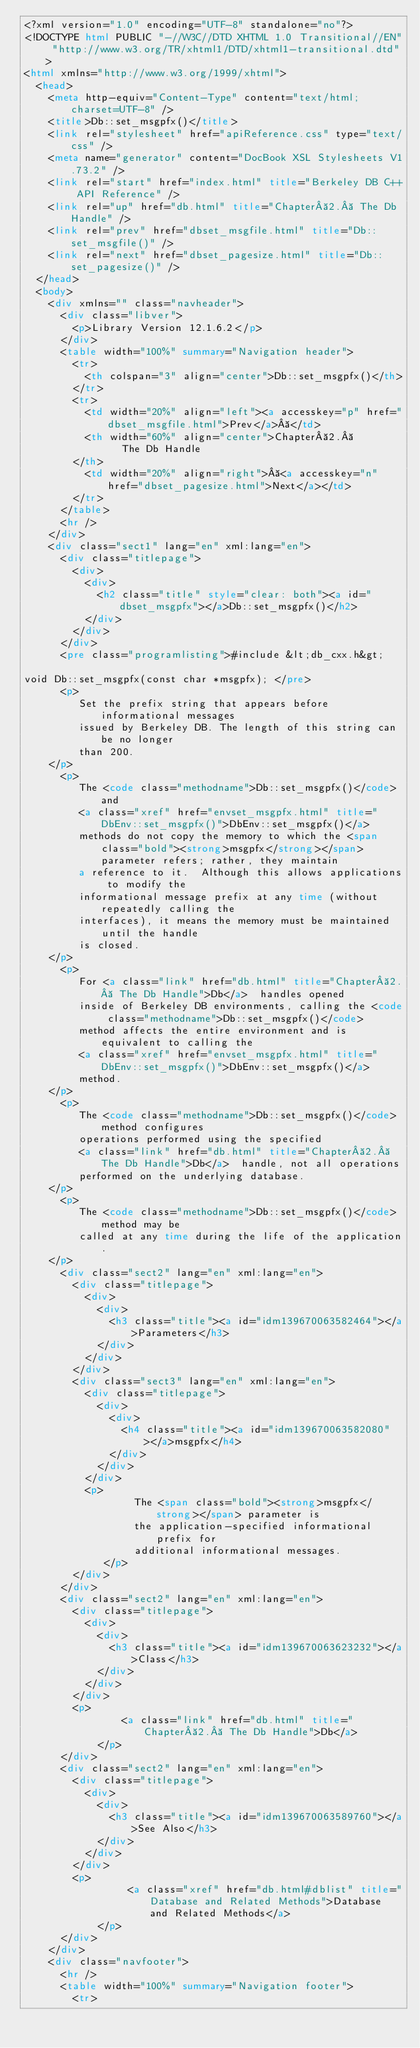Convert code to text. <code><loc_0><loc_0><loc_500><loc_500><_HTML_><?xml version="1.0" encoding="UTF-8" standalone="no"?>
<!DOCTYPE html PUBLIC "-//W3C//DTD XHTML 1.0 Transitional//EN" "http://www.w3.org/TR/xhtml1/DTD/xhtml1-transitional.dtd">
<html xmlns="http://www.w3.org/1999/xhtml">
  <head>
    <meta http-equiv="Content-Type" content="text/html; charset=UTF-8" />
    <title>Db::set_msgpfx()</title>
    <link rel="stylesheet" href="apiReference.css" type="text/css" />
    <meta name="generator" content="DocBook XSL Stylesheets V1.73.2" />
    <link rel="start" href="index.html" title="Berkeley DB C++ API Reference" />
    <link rel="up" href="db.html" title="Chapter 2.  The Db Handle" />
    <link rel="prev" href="dbset_msgfile.html" title="Db::set_msgfile()" />
    <link rel="next" href="dbset_pagesize.html" title="Db::set_pagesize()" />
  </head>
  <body>
    <div xmlns="" class="navheader">
      <div class="libver">
        <p>Library Version 12.1.6.2</p>
      </div>
      <table width="100%" summary="Navigation header">
        <tr>
          <th colspan="3" align="center">Db::set_msgpfx()</th>
        </tr>
        <tr>
          <td width="20%" align="left"><a accesskey="p" href="dbset_msgfile.html">Prev</a> </td>
          <th width="60%" align="center">Chapter 2. 
                The Db Handle
        </th>
          <td width="20%" align="right"> <a accesskey="n" href="dbset_pagesize.html">Next</a></td>
        </tr>
      </table>
      <hr />
    </div>
    <div class="sect1" lang="en" xml:lang="en">
      <div class="titlepage">
        <div>
          <div>
            <h2 class="title" style="clear: both"><a id="dbset_msgpfx"></a>Db::set_msgpfx()</h2>
          </div>
        </div>
      </div>
      <pre class="programlisting">#include &lt;db_cxx.h&gt;

void Db::set_msgpfx(const char *msgpfx); </pre>
      <p>
         Set the prefix string that appears before informational messages
         issued by Berkeley DB. The length of this string can be no longer 
         than 200.
    </p>
      <p>
         The <code class="methodname">Db::set_msgpfx()</code> and 
         <a class="xref" href="envset_msgpfx.html" title="DbEnv::set_msgpfx()">DbEnv::set_msgpfx()</a> 
         methods do not copy the memory to which the <span class="bold"><strong>msgpfx</strong></span> parameter refers; rather, they maintain
         a reference to it.  Although this allows applications to modify the
         informational message prefix at any time (without repeatedly calling the
         interfaces), it means the memory must be maintained until the handle
         is closed.
    </p>
      <p>
         For <a class="link" href="db.html" title="Chapter 2.  The Db Handle">Db</a>  handles opened
         inside of Berkeley DB environments, calling the <code class="methodname">Db::set_msgpfx()</code>
         method affects the entire environment and is equivalent to calling the
         <a class="xref" href="envset_msgpfx.html" title="DbEnv::set_msgpfx()">DbEnv::set_msgpfx()</a> 
         method.
    </p>
      <p>
         The <code class="methodname">Db::set_msgpfx()</code> method configures
         operations performed using the specified 
         <a class="link" href="db.html" title="Chapter 2.  The Db Handle">Db</a>  handle, not all operations
         performed on the underlying database.
    </p>
      <p>
         The <code class="methodname">Db::set_msgpfx()</code> method may be
         called at any time during the life of the application.
    </p>
      <div class="sect2" lang="en" xml:lang="en">
        <div class="titlepage">
          <div>
            <div>
              <h3 class="title"><a id="idm139670063582464"></a>Parameters</h3>
            </div>
          </div>
        </div>
        <div class="sect3" lang="en" xml:lang="en">
          <div class="titlepage">
            <div>
              <div>
                <h4 class="title"><a id="idm139670063582080"></a>msgpfx</h4>
              </div>
            </div>
          </div>
          <p>
                  The <span class="bold"><strong>msgpfx</strong></span> parameter is
                  the application-specified informational prefix for
                  additional informational messages.
             </p>
        </div>
      </div>
      <div class="sect2" lang="en" xml:lang="en">
        <div class="titlepage">
          <div>
            <div>
              <h3 class="title"><a id="idm139670063623232"></a>Class</h3>
            </div>
          </div>
        </div>
        <p>
                <a class="link" href="db.html" title="Chapter 2.  The Db Handle">Db</a>  
            </p>
      </div>
      <div class="sect2" lang="en" xml:lang="en">
        <div class="titlepage">
          <div>
            <div>
              <h3 class="title"><a id="idm139670063589760"></a>See Also</h3>
            </div>
          </div>
        </div>
        <p>
                 <a class="xref" href="db.html#dblist" title="Database and Related Methods">Database and Related Methods</a> 
            </p>
      </div>
    </div>
    <div class="navfooter">
      <hr />
      <table width="100%" summary="Navigation footer">
        <tr></code> 